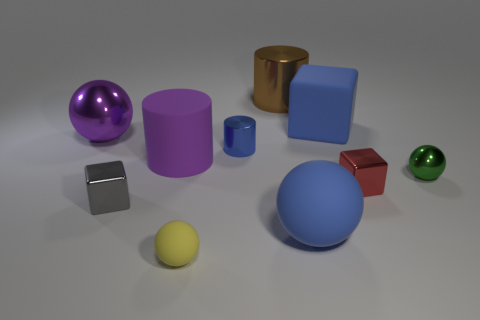Is the brown thing made of the same material as the big blue object behind the red metallic object?
Ensure brevity in your answer.  No. What material is the brown cylinder that is the same size as the matte cube?
Make the answer very short. Metal. Is there a large green cylinder made of the same material as the large brown cylinder?
Keep it short and to the point. No. There is a tiny ball behind the big blue rubber thing that is in front of the small green sphere; is there a matte object behind it?
Provide a short and direct response. Yes. There is a yellow rubber object that is the same size as the gray thing; what is its shape?
Keep it short and to the point. Sphere. There is a metal ball left of the green shiny sphere; is it the same size as the ball on the right side of the large blue block?
Provide a succinct answer. No. What number of red shiny cubes are there?
Provide a short and direct response. 1. There is a sphere that is on the right side of the blue object behind the ball that is to the left of the gray cube; how big is it?
Your response must be concise. Small. Does the large cube have the same color as the tiny metallic cylinder?
Offer a very short reply. Yes. Is there any other thing that has the same size as the green ball?
Keep it short and to the point. Yes. 